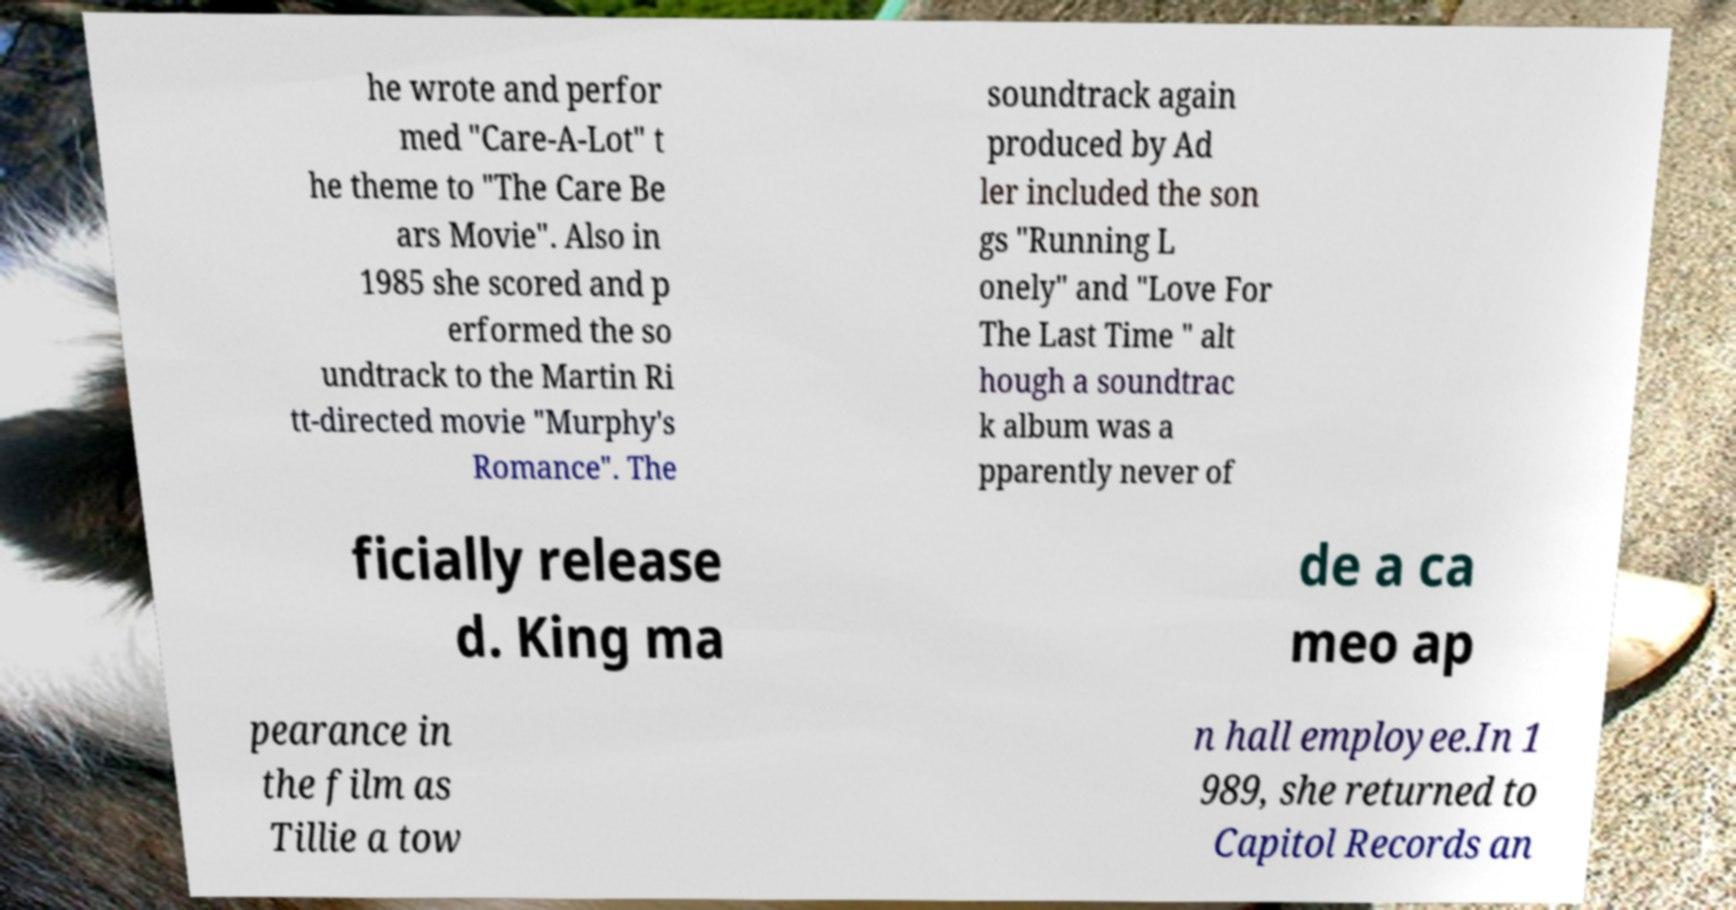Can you accurately transcribe the text from the provided image for me? he wrote and perfor med "Care-A-Lot" t he theme to "The Care Be ars Movie". Also in 1985 she scored and p erformed the so undtrack to the Martin Ri tt-directed movie "Murphy's Romance". The soundtrack again produced by Ad ler included the son gs "Running L onely" and "Love For The Last Time " alt hough a soundtrac k album was a pparently never of ficially release d. King ma de a ca meo ap pearance in the film as Tillie a tow n hall employee.In 1 989, she returned to Capitol Records an 